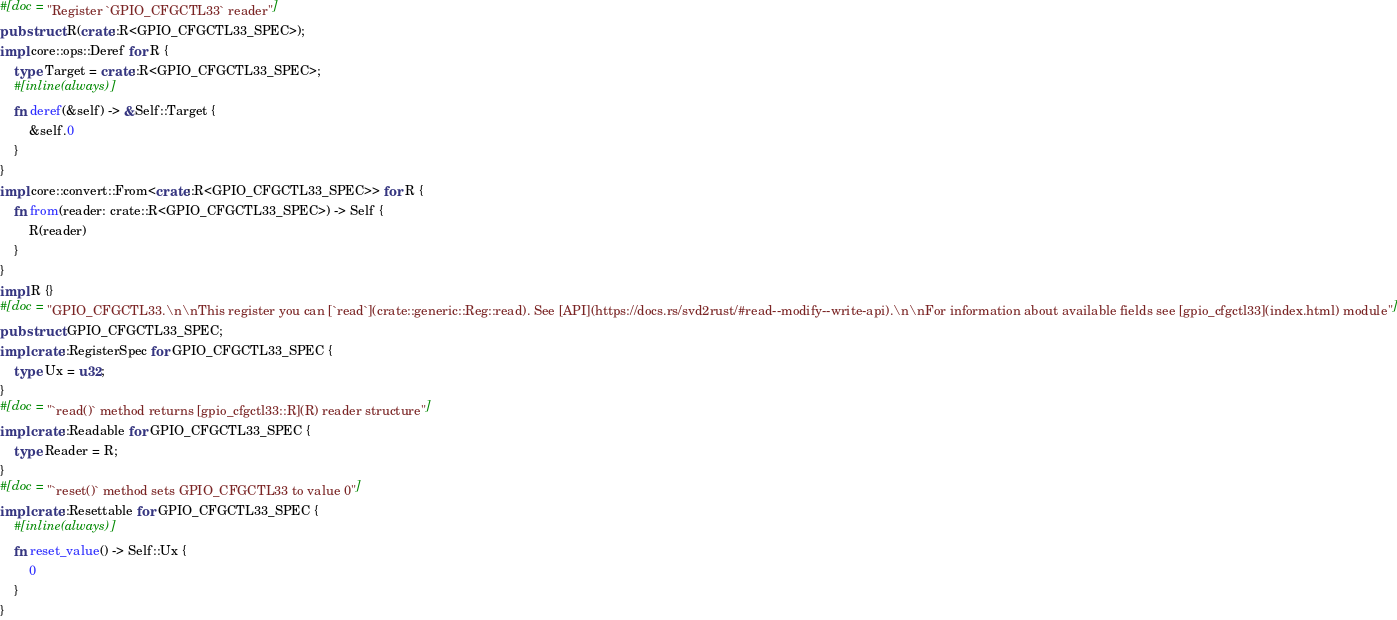Convert code to text. <code><loc_0><loc_0><loc_500><loc_500><_Rust_>#[doc = "Register `GPIO_CFGCTL33` reader"]
pub struct R(crate::R<GPIO_CFGCTL33_SPEC>);
impl core::ops::Deref for R {
    type Target = crate::R<GPIO_CFGCTL33_SPEC>;
    #[inline(always)]
    fn deref(&self) -> &Self::Target {
        &self.0
    }
}
impl core::convert::From<crate::R<GPIO_CFGCTL33_SPEC>> for R {
    fn from(reader: crate::R<GPIO_CFGCTL33_SPEC>) -> Self {
        R(reader)
    }
}
impl R {}
#[doc = "GPIO_CFGCTL33.\n\nThis register you can [`read`](crate::generic::Reg::read). See [API](https://docs.rs/svd2rust/#read--modify--write-api).\n\nFor information about available fields see [gpio_cfgctl33](index.html) module"]
pub struct GPIO_CFGCTL33_SPEC;
impl crate::RegisterSpec for GPIO_CFGCTL33_SPEC {
    type Ux = u32;
}
#[doc = "`read()` method returns [gpio_cfgctl33::R](R) reader structure"]
impl crate::Readable for GPIO_CFGCTL33_SPEC {
    type Reader = R;
}
#[doc = "`reset()` method sets GPIO_CFGCTL33 to value 0"]
impl crate::Resettable for GPIO_CFGCTL33_SPEC {
    #[inline(always)]
    fn reset_value() -> Self::Ux {
        0
    }
}
</code> 